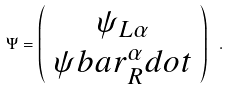Convert formula to latex. <formula><loc_0><loc_0><loc_500><loc_500>\Psi = \left ( \begin{array} { c } \psi _ { L \alpha } \\ \psi b a r _ { R } ^ { \alpha } d o t \end{array} \right ) \ .</formula> 